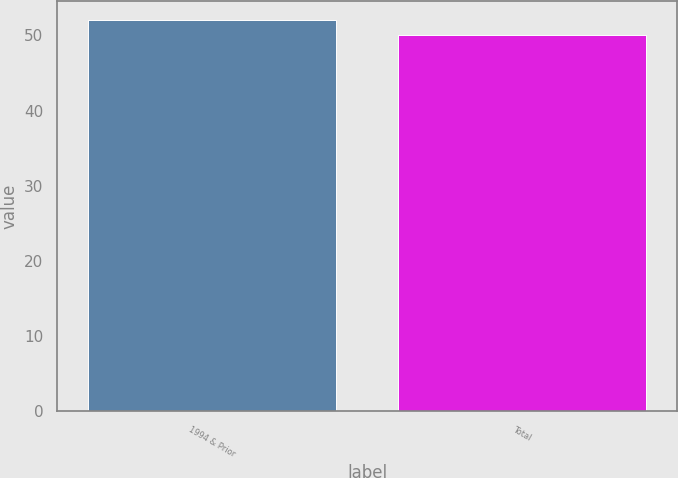<chart> <loc_0><loc_0><loc_500><loc_500><bar_chart><fcel>1994 & Prior<fcel>Total<nl><fcel>52<fcel>50<nl></chart> 